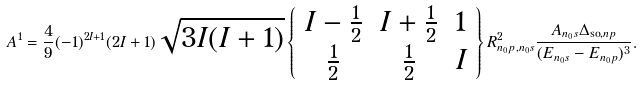<formula> <loc_0><loc_0><loc_500><loc_500>A ^ { 1 } = \frac { 4 } { 9 } ( - 1 ) ^ { 2 I + 1 } ( 2 I + 1 ) \sqrt { 3 I ( I + 1 ) } \left \{ \begin{array} { c c c } I - \frac { 1 } { 2 } & I + \frac { 1 } { 2 } & 1 \\ \frac { 1 } { 2 } & \frac { 1 } { 2 } & I \end{array} \right \} R _ { n _ { 0 } p , n _ { 0 } s } ^ { 2 } \frac { A _ { n _ { 0 } s } \Delta _ { \text {so} , n p } } { ( E _ { n _ { 0 } s } - E _ { n _ { 0 } p } ) ^ { 3 } } .</formula> 